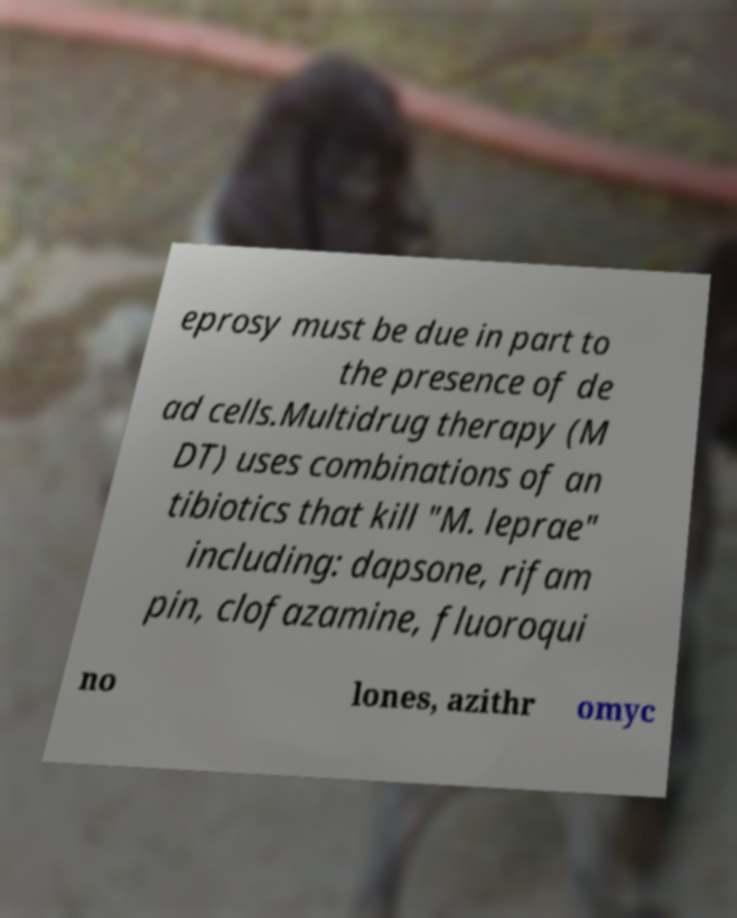For documentation purposes, I need the text within this image transcribed. Could you provide that? eprosy must be due in part to the presence of de ad cells.Multidrug therapy (M DT) uses combinations of an tibiotics that kill "M. leprae" including: dapsone, rifam pin, clofazamine, fluoroqui no lones, azithr omyc 